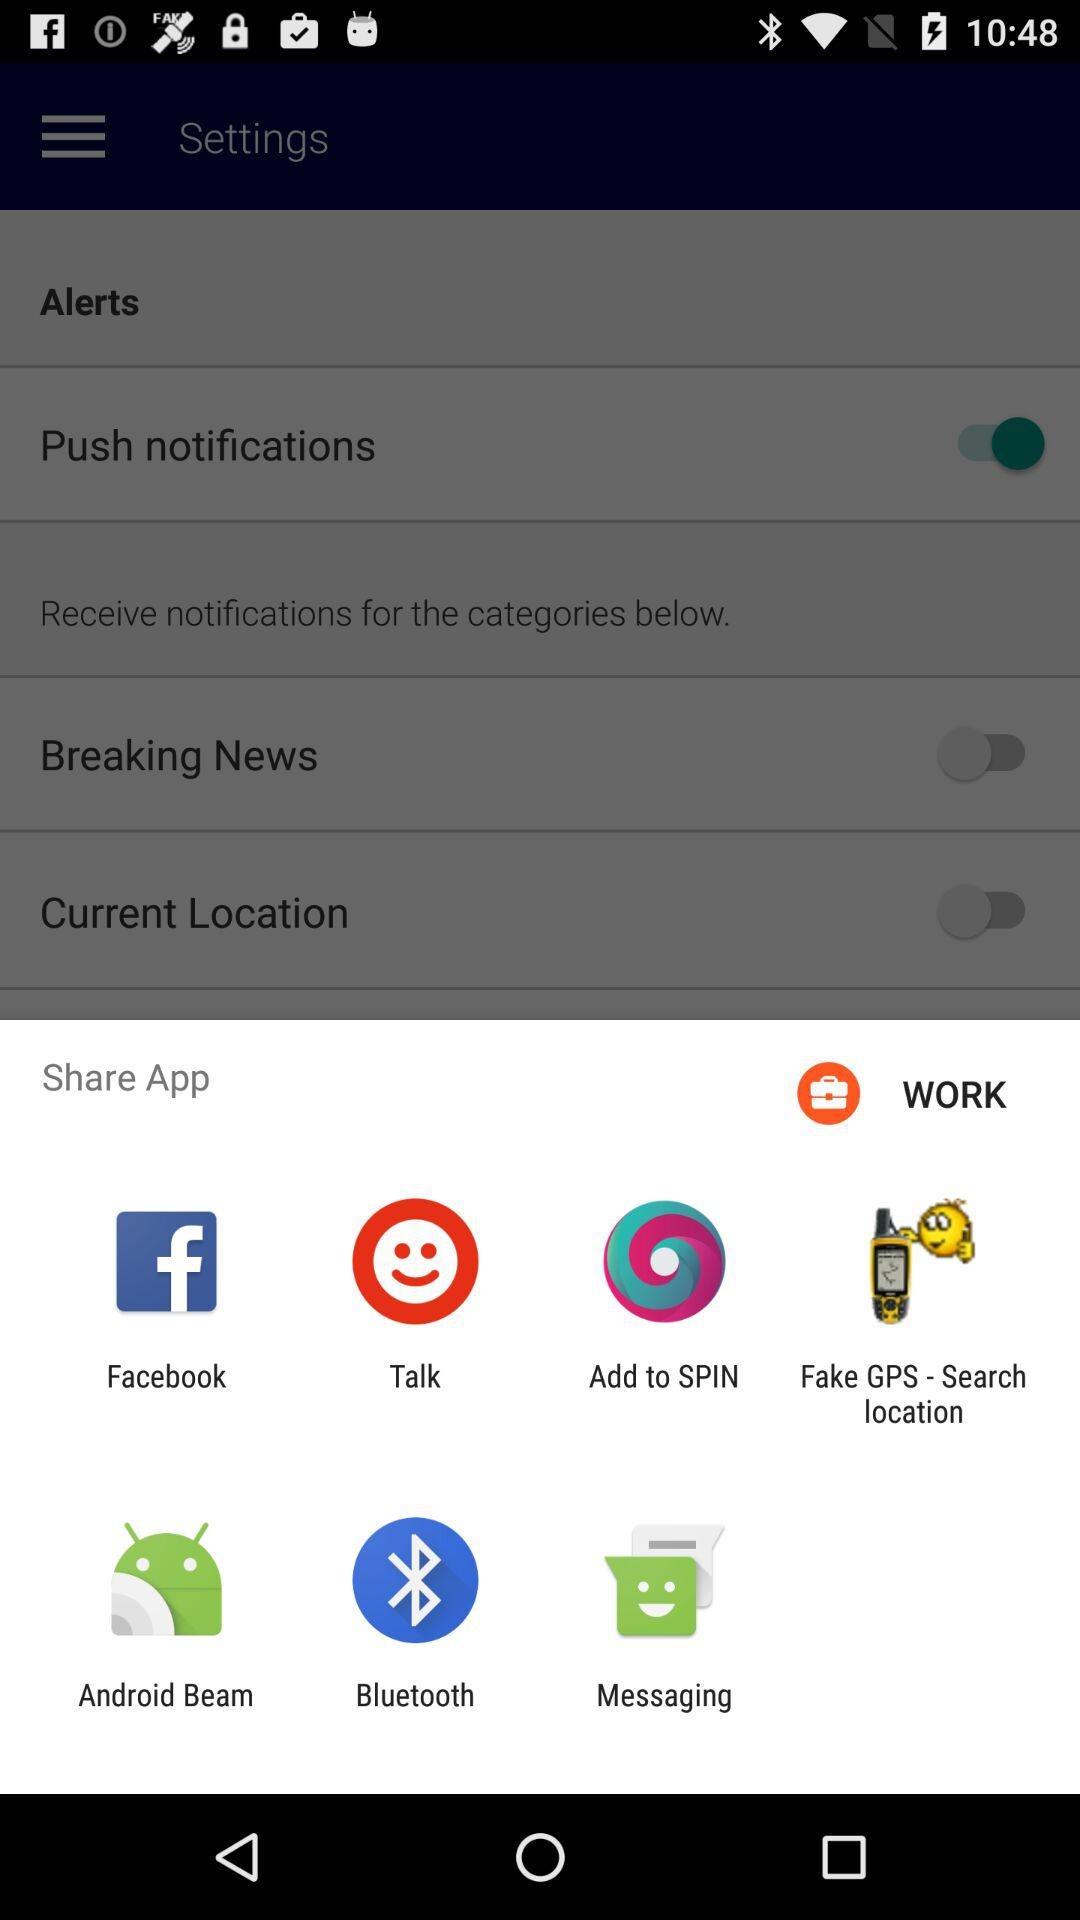What is the status of "Share App"?
When the provided information is insufficient, respond with <no answer>. <no answer> 